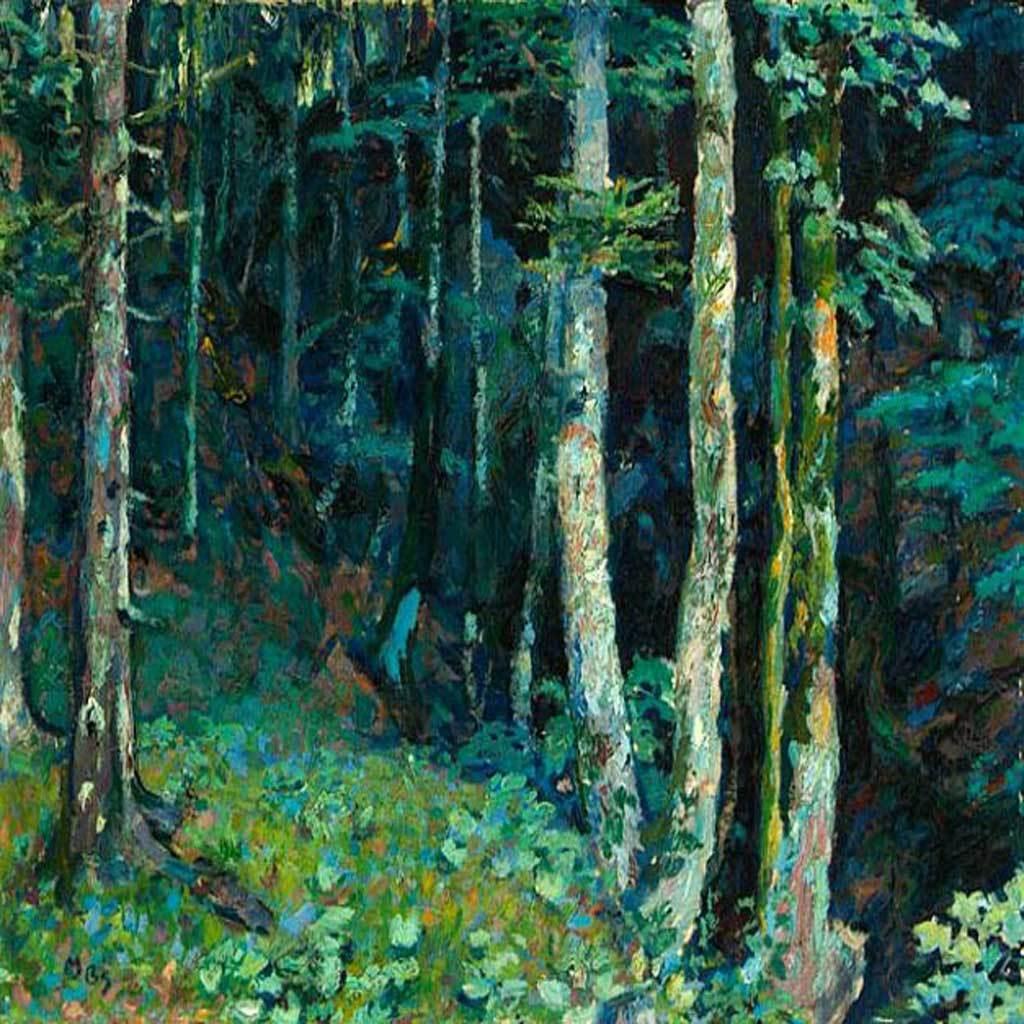Describe this image in one or two sentences. It is a painted image. In this image there are plants and trees. 